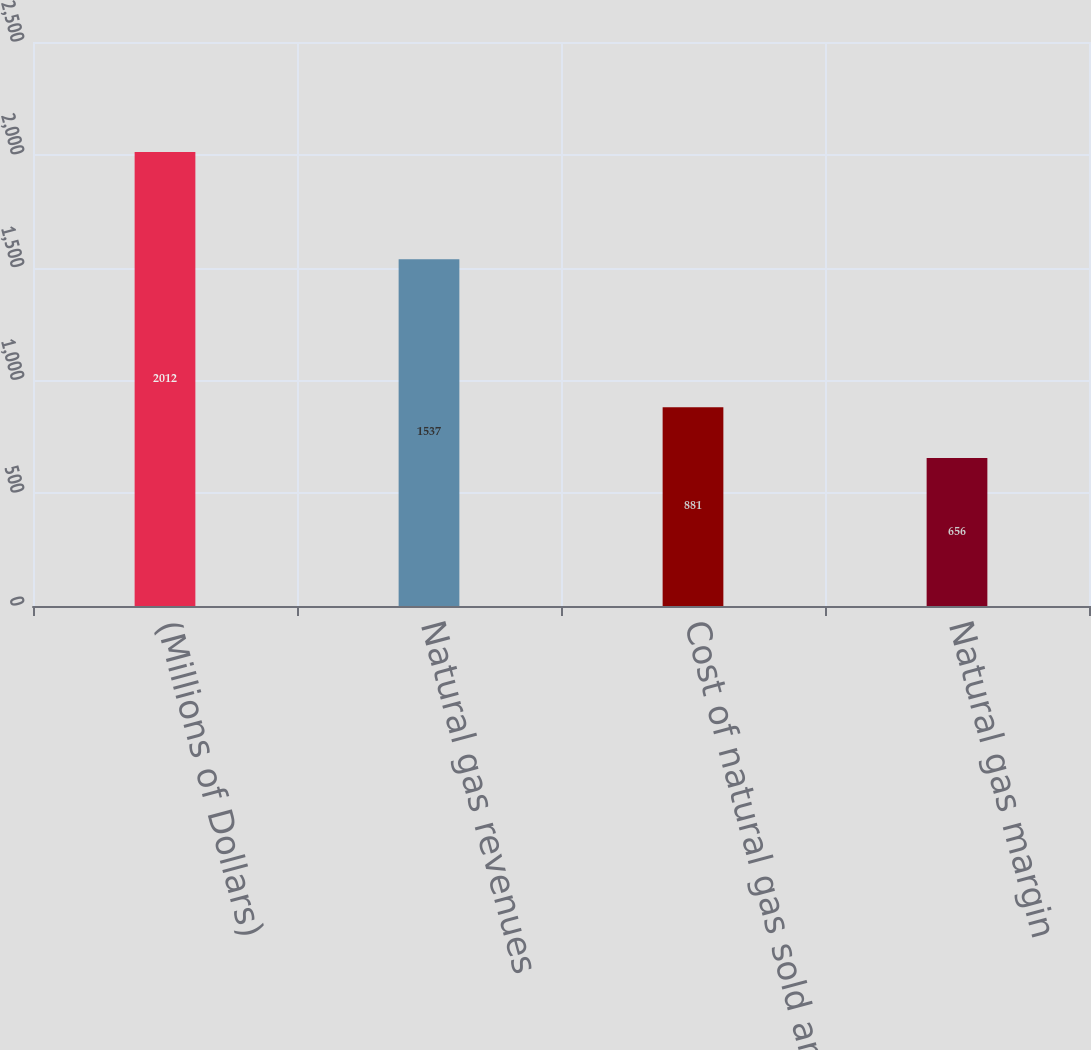<chart> <loc_0><loc_0><loc_500><loc_500><bar_chart><fcel>(Millions of Dollars)<fcel>Natural gas revenues<fcel>Cost of natural gas sold and<fcel>Natural gas margin<nl><fcel>2012<fcel>1537<fcel>881<fcel>656<nl></chart> 